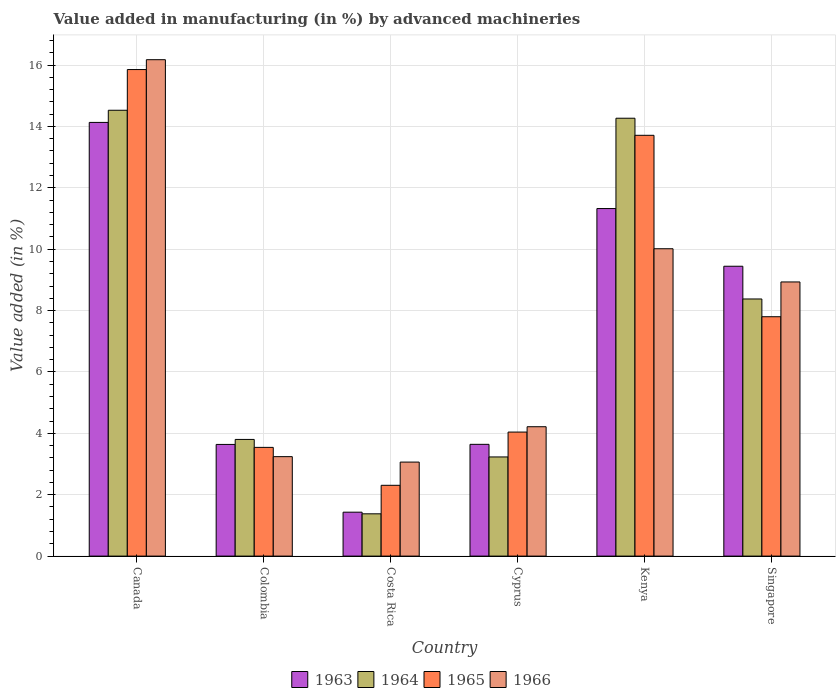How many groups of bars are there?
Keep it short and to the point. 6. Are the number of bars per tick equal to the number of legend labels?
Offer a very short reply. Yes. Are the number of bars on each tick of the X-axis equal?
Offer a terse response. Yes. How many bars are there on the 4th tick from the left?
Provide a succinct answer. 4. What is the label of the 4th group of bars from the left?
Keep it short and to the point. Cyprus. In how many cases, is the number of bars for a given country not equal to the number of legend labels?
Your answer should be very brief. 0. What is the percentage of value added in manufacturing by advanced machineries in 1963 in Colombia?
Give a very brief answer. 3.64. Across all countries, what is the maximum percentage of value added in manufacturing by advanced machineries in 1965?
Provide a short and direct response. 15.85. Across all countries, what is the minimum percentage of value added in manufacturing by advanced machineries in 1964?
Your answer should be very brief. 1.38. In which country was the percentage of value added in manufacturing by advanced machineries in 1966 maximum?
Make the answer very short. Canada. In which country was the percentage of value added in manufacturing by advanced machineries in 1966 minimum?
Your answer should be very brief. Costa Rica. What is the total percentage of value added in manufacturing by advanced machineries in 1965 in the graph?
Provide a succinct answer. 47.25. What is the difference between the percentage of value added in manufacturing by advanced machineries in 1965 in Canada and that in Colombia?
Make the answer very short. 12.31. What is the difference between the percentage of value added in manufacturing by advanced machineries in 1965 in Cyprus and the percentage of value added in manufacturing by advanced machineries in 1964 in Colombia?
Keep it short and to the point. 0.24. What is the average percentage of value added in manufacturing by advanced machineries in 1963 per country?
Your response must be concise. 7.27. What is the difference between the percentage of value added in manufacturing by advanced machineries of/in 1963 and percentage of value added in manufacturing by advanced machineries of/in 1964 in Costa Rica?
Your answer should be compact. 0.05. What is the ratio of the percentage of value added in manufacturing by advanced machineries in 1964 in Canada to that in Kenya?
Ensure brevity in your answer.  1.02. What is the difference between the highest and the second highest percentage of value added in manufacturing by advanced machineries in 1965?
Your answer should be very brief. -5.91. What is the difference between the highest and the lowest percentage of value added in manufacturing by advanced machineries in 1964?
Your answer should be very brief. 13.15. Is it the case that in every country, the sum of the percentage of value added in manufacturing by advanced machineries in 1963 and percentage of value added in manufacturing by advanced machineries in 1964 is greater than the sum of percentage of value added in manufacturing by advanced machineries in 1965 and percentage of value added in manufacturing by advanced machineries in 1966?
Provide a succinct answer. No. What does the 4th bar from the left in Cyprus represents?
Keep it short and to the point. 1966. What does the 1st bar from the right in Canada represents?
Give a very brief answer. 1966. Are all the bars in the graph horizontal?
Give a very brief answer. No. What is the difference between two consecutive major ticks on the Y-axis?
Provide a short and direct response. 2. Does the graph contain any zero values?
Make the answer very short. No. Where does the legend appear in the graph?
Keep it short and to the point. Bottom center. How many legend labels are there?
Make the answer very short. 4. What is the title of the graph?
Your answer should be compact. Value added in manufacturing (in %) by advanced machineries. What is the label or title of the Y-axis?
Keep it short and to the point. Value added (in %). What is the Value added (in %) in 1963 in Canada?
Keep it short and to the point. 14.13. What is the Value added (in %) in 1964 in Canada?
Your answer should be very brief. 14.53. What is the Value added (in %) in 1965 in Canada?
Provide a succinct answer. 15.85. What is the Value added (in %) in 1966 in Canada?
Ensure brevity in your answer.  16.17. What is the Value added (in %) in 1963 in Colombia?
Give a very brief answer. 3.64. What is the Value added (in %) of 1964 in Colombia?
Make the answer very short. 3.8. What is the Value added (in %) of 1965 in Colombia?
Make the answer very short. 3.54. What is the Value added (in %) in 1966 in Colombia?
Give a very brief answer. 3.24. What is the Value added (in %) of 1963 in Costa Rica?
Your answer should be very brief. 1.43. What is the Value added (in %) of 1964 in Costa Rica?
Ensure brevity in your answer.  1.38. What is the Value added (in %) in 1965 in Costa Rica?
Your answer should be compact. 2.31. What is the Value added (in %) in 1966 in Costa Rica?
Keep it short and to the point. 3.06. What is the Value added (in %) in 1963 in Cyprus?
Give a very brief answer. 3.64. What is the Value added (in %) of 1964 in Cyprus?
Your answer should be compact. 3.23. What is the Value added (in %) in 1965 in Cyprus?
Ensure brevity in your answer.  4.04. What is the Value added (in %) of 1966 in Cyprus?
Your answer should be compact. 4.22. What is the Value added (in %) in 1963 in Kenya?
Ensure brevity in your answer.  11.32. What is the Value added (in %) of 1964 in Kenya?
Offer a terse response. 14.27. What is the Value added (in %) in 1965 in Kenya?
Provide a short and direct response. 13.71. What is the Value added (in %) of 1966 in Kenya?
Keep it short and to the point. 10.01. What is the Value added (in %) in 1963 in Singapore?
Offer a very short reply. 9.44. What is the Value added (in %) of 1964 in Singapore?
Offer a terse response. 8.38. What is the Value added (in %) of 1965 in Singapore?
Make the answer very short. 7.8. What is the Value added (in %) in 1966 in Singapore?
Make the answer very short. 8.93. Across all countries, what is the maximum Value added (in %) of 1963?
Give a very brief answer. 14.13. Across all countries, what is the maximum Value added (in %) of 1964?
Offer a very short reply. 14.53. Across all countries, what is the maximum Value added (in %) of 1965?
Your answer should be compact. 15.85. Across all countries, what is the maximum Value added (in %) of 1966?
Your answer should be very brief. 16.17. Across all countries, what is the minimum Value added (in %) in 1963?
Give a very brief answer. 1.43. Across all countries, what is the minimum Value added (in %) in 1964?
Your answer should be very brief. 1.38. Across all countries, what is the minimum Value added (in %) of 1965?
Your response must be concise. 2.31. Across all countries, what is the minimum Value added (in %) of 1966?
Your response must be concise. 3.06. What is the total Value added (in %) in 1963 in the graph?
Provide a short and direct response. 43.61. What is the total Value added (in %) in 1964 in the graph?
Ensure brevity in your answer.  45.58. What is the total Value added (in %) of 1965 in the graph?
Your answer should be very brief. 47.25. What is the total Value added (in %) of 1966 in the graph?
Offer a very short reply. 45.64. What is the difference between the Value added (in %) in 1963 in Canada and that in Colombia?
Your answer should be compact. 10.49. What is the difference between the Value added (in %) in 1964 in Canada and that in Colombia?
Make the answer very short. 10.72. What is the difference between the Value added (in %) in 1965 in Canada and that in Colombia?
Offer a very short reply. 12.31. What is the difference between the Value added (in %) of 1966 in Canada and that in Colombia?
Give a very brief answer. 12.93. What is the difference between the Value added (in %) of 1963 in Canada and that in Costa Rica?
Your answer should be compact. 12.7. What is the difference between the Value added (in %) of 1964 in Canada and that in Costa Rica?
Offer a very short reply. 13.15. What is the difference between the Value added (in %) of 1965 in Canada and that in Costa Rica?
Keep it short and to the point. 13.55. What is the difference between the Value added (in %) in 1966 in Canada and that in Costa Rica?
Ensure brevity in your answer.  13.11. What is the difference between the Value added (in %) in 1963 in Canada and that in Cyprus?
Offer a very short reply. 10.49. What is the difference between the Value added (in %) in 1964 in Canada and that in Cyprus?
Make the answer very short. 11.3. What is the difference between the Value added (in %) in 1965 in Canada and that in Cyprus?
Provide a short and direct response. 11.81. What is the difference between the Value added (in %) in 1966 in Canada and that in Cyprus?
Your answer should be very brief. 11.96. What is the difference between the Value added (in %) of 1963 in Canada and that in Kenya?
Make the answer very short. 2.81. What is the difference between the Value added (in %) of 1964 in Canada and that in Kenya?
Give a very brief answer. 0.26. What is the difference between the Value added (in %) of 1965 in Canada and that in Kenya?
Offer a terse response. 2.14. What is the difference between the Value added (in %) in 1966 in Canada and that in Kenya?
Your answer should be very brief. 6.16. What is the difference between the Value added (in %) in 1963 in Canada and that in Singapore?
Keep it short and to the point. 4.69. What is the difference between the Value added (in %) of 1964 in Canada and that in Singapore?
Provide a succinct answer. 6.15. What is the difference between the Value added (in %) in 1965 in Canada and that in Singapore?
Offer a terse response. 8.05. What is the difference between the Value added (in %) in 1966 in Canada and that in Singapore?
Your answer should be very brief. 7.24. What is the difference between the Value added (in %) of 1963 in Colombia and that in Costa Rica?
Provide a short and direct response. 2.21. What is the difference between the Value added (in %) of 1964 in Colombia and that in Costa Rica?
Your answer should be very brief. 2.42. What is the difference between the Value added (in %) in 1965 in Colombia and that in Costa Rica?
Your response must be concise. 1.24. What is the difference between the Value added (in %) of 1966 in Colombia and that in Costa Rica?
Provide a short and direct response. 0.18. What is the difference between the Value added (in %) in 1963 in Colombia and that in Cyprus?
Offer a terse response. -0. What is the difference between the Value added (in %) of 1964 in Colombia and that in Cyprus?
Your answer should be very brief. 0.57. What is the difference between the Value added (in %) in 1965 in Colombia and that in Cyprus?
Ensure brevity in your answer.  -0.5. What is the difference between the Value added (in %) of 1966 in Colombia and that in Cyprus?
Ensure brevity in your answer.  -0.97. What is the difference between the Value added (in %) in 1963 in Colombia and that in Kenya?
Your answer should be compact. -7.69. What is the difference between the Value added (in %) of 1964 in Colombia and that in Kenya?
Provide a short and direct response. -10.47. What is the difference between the Value added (in %) of 1965 in Colombia and that in Kenya?
Your answer should be compact. -10.17. What is the difference between the Value added (in %) of 1966 in Colombia and that in Kenya?
Provide a short and direct response. -6.77. What is the difference between the Value added (in %) of 1963 in Colombia and that in Singapore?
Your answer should be very brief. -5.81. What is the difference between the Value added (in %) in 1964 in Colombia and that in Singapore?
Provide a succinct answer. -4.58. What is the difference between the Value added (in %) in 1965 in Colombia and that in Singapore?
Give a very brief answer. -4.26. What is the difference between the Value added (in %) in 1966 in Colombia and that in Singapore?
Give a very brief answer. -5.69. What is the difference between the Value added (in %) in 1963 in Costa Rica and that in Cyprus?
Keep it short and to the point. -2.21. What is the difference between the Value added (in %) in 1964 in Costa Rica and that in Cyprus?
Offer a very short reply. -1.85. What is the difference between the Value added (in %) of 1965 in Costa Rica and that in Cyprus?
Offer a terse response. -1.73. What is the difference between the Value added (in %) of 1966 in Costa Rica and that in Cyprus?
Offer a terse response. -1.15. What is the difference between the Value added (in %) of 1963 in Costa Rica and that in Kenya?
Your answer should be very brief. -9.89. What is the difference between the Value added (in %) in 1964 in Costa Rica and that in Kenya?
Offer a very short reply. -12.89. What is the difference between the Value added (in %) in 1965 in Costa Rica and that in Kenya?
Give a very brief answer. -11.4. What is the difference between the Value added (in %) of 1966 in Costa Rica and that in Kenya?
Provide a short and direct response. -6.95. What is the difference between the Value added (in %) in 1963 in Costa Rica and that in Singapore?
Give a very brief answer. -8.01. What is the difference between the Value added (in %) of 1964 in Costa Rica and that in Singapore?
Offer a terse response. -7. What is the difference between the Value added (in %) in 1965 in Costa Rica and that in Singapore?
Give a very brief answer. -5.49. What is the difference between the Value added (in %) in 1966 in Costa Rica and that in Singapore?
Your response must be concise. -5.87. What is the difference between the Value added (in %) in 1963 in Cyprus and that in Kenya?
Provide a short and direct response. -7.68. What is the difference between the Value added (in %) in 1964 in Cyprus and that in Kenya?
Keep it short and to the point. -11.04. What is the difference between the Value added (in %) in 1965 in Cyprus and that in Kenya?
Keep it short and to the point. -9.67. What is the difference between the Value added (in %) of 1966 in Cyprus and that in Kenya?
Provide a short and direct response. -5.8. What is the difference between the Value added (in %) in 1963 in Cyprus and that in Singapore?
Your response must be concise. -5.8. What is the difference between the Value added (in %) of 1964 in Cyprus and that in Singapore?
Give a very brief answer. -5.15. What is the difference between the Value added (in %) of 1965 in Cyprus and that in Singapore?
Provide a short and direct response. -3.76. What is the difference between the Value added (in %) in 1966 in Cyprus and that in Singapore?
Make the answer very short. -4.72. What is the difference between the Value added (in %) in 1963 in Kenya and that in Singapore?
Provide a short and direct response. 1.88. What is the difference between the Value added (in %) of 1964 in Kenya and that in Singapore?
Your answer should be compact. 5.89. What is the difference between the Value added (in %) in 1965 in Kenya and that in Singapore?
Keep it short and to the point. 5.91. What is the difference between the Value added (in %) in 1966 in Kenya and that in Singapore?
Provide a short and direct response. 1.08. What is the difference between the Value added (in %) of 1963 in Canada and the Value added (in %) of 1964 in Colombia?
Keep it short and to the point. 10.33. What is the difference between the Value added (in %) in 1963 in Canada and the Value added (in %) in 1965 in Colombia?
Offer a terse response. 10.59. What is the difference between the Value added (in %) in 1963 in Canada and the Value added (in %) in 1966 in Colombia?
Provide a succinct answer. 10.89. What is the difference between the Value added (in %) of 1964 in Canada and the Value added (in %) of 1965 in Colombia?
Your response must be concise. 10.98. What is the difference between the Value added (in %) of 1964 in Canada and the Value added (in %) of 1966 in Colombia?
Provide a succinct answer. 11.29. What is the difference between the Value added (in %) in 1965 in Canada and the Value added (in %) in 1966 in Colombia?
Your answer should be very brief. 12.61. What is the difference between the Value added (in %) in 1963 in Canada and the Value added (in %) in 1964 in Costa Rica?
Keep it short and to the point. 12.75. What is the difference between the Value added (in %) in 1963 in Canada and the Value added (in %) in 1965 in Costa Rica?
Your response must be concise. 11.82. What is the difference between the Value added (in %) of 1963 in Canada and the Value added (in %) of 1966 in Costa Rica?
Provide a succinct answer. 11.07. What is the difference between the Value added (in %) of 1964 in Canada and the Value added (in %) of 1965 in Costa Rica?
Provide a short and direct response. 12.22. What is the difference between the Value added (in %) of 1964 in Canada and the Value added (in %) of 1966 in Costa Rica?
Your response must be concise. 11.46. What is the difference between the Value added (in %) in 1965 in Canada and the Value added (in %) in 1966 in Costa Rica?
Offer a very short reply. 12.79. What is the difference between the Value added (in %) in 1963 in Canada and the Value added (in %) in 1964 in Cyprus?
Make the answer very short. 10.9. What is the difference between the Value added (in %) in 1963 in Canada and the Value added (in %) in 1965 in Cyprus?
Make the answer very short. 10.09. What is the difference between the Value added (in %) in 1963 in Canada and the Value added (in %) in 1966 in Cyprus?
Your response must be concise. 9.92. What is the difference between the Value added (in %) in 1964 in Canada and the Value added (in %) in 1965 in Cyprus?
Provide a succinct answer. 10.49. What is the difference between the Value added (in %) of 1964 in Canada and the Value added (in %) of 1966 in Cyprus?
Your response must be concise. 10.31. What is the difference between the Value added (in %) in 1965 in Canada and the Value added (in %) in 1966 in Cyprus?
Keep it short and to the point. 11.64. What is the difference between the Value added (in %) in 1963 in Canada and the Value added (in %) in 1964 in Kenya?
Your answer should be compact. -0.14. What is the difference between the Value added (in %) in 1963 in Canada and the Value added (in %) in 1965 in Kenya?
Offer a very short reply. 0.42. What is the difference between the Value added (in %) in 1963 in Canada and the Value added (in %) in 1966 in Kenya?
Your answer should be very brief. 4.12. What is the difference between the Value added (in %) in 1964 in Canada and the Value added (in %) in 1965 in Kenya?
Ensure brevity in your answer.  0.82. What is the difference between the Value added (in %) of 1964 in Canada and the Value added (in %) of 1966 in Kenya?
Offer a very short reply. 4.51. What is the difference between the Value added (in %) in 1965 in Canada and the Value added (in %) in 1966 in Kenya?
Ensure brevity in your answer.  5.84. What is the difference between the Value added (in %) of 1963 in Canada and the Value added (in %) of 1964 in Singapore?
Give a very brief answer. 5.75. What is the difference between the Value added (in %) in 1963 in Canada and the Value added (in %) in 1965 in Singapore?
Provide a succinct answer. 6.33. What is the difference between the Value added (in %) in 1963 in Canada and the Value added (in %) in 1966 in Singapore?
Provide a succinct answer. 5.2. What is the difference between the Value added (in %) in 1964 in Canada and the Value added (in %) in 1965 in Singapore?
Provide a short and direct response. 6.73. What is the difference between the Value added (in %) of 1964 in Canada and the Value added (in %) of 1966 in Singapore?
Provide a succinct answer. 5.59. What is the difference between the Value added (in %) of 1965 in Canada and the Value added (in %) of 1966 in Singapore?
Your answer should be very brief. 6.92. What is the difference between the Value added (in %) of 1963 in Colombia and the Value added (in %) of 1964 in Costa Rica?
Provide a short and direct response. 2.26. What is the difference between the Value added (in %) in 1963 in Colombia and the Value added (in %) in 1965 in Costa Rica?
Provide a short and direct response. 1.33. What is the difference between the Value added (in %) of 1963 in Colombia and the Value added (in %) of 1966 in Costa Rica?
Your answer should be very brief. 0.57. What is the difference between the Value added (in %) in 1964 in Colombia and the Value added (in %) in 1965 in Costa Rica?
Your answer should be very brief. 1.49. What is the difference between the Value added (in %) in 1964 in Colombia and the Value added (in %) in 1966 in Costa Rica?
Make the answer very short. 0.74. What is the difference between the Value added (in %) in 1965 in Colombia and the Value added (in %) in 1966 in Costa Rica?
Your response must be concise. 0.48. What is the difference between the Value added (in %) of 1963 in Colombia and the Value added (in %) of 1964 in Cyprus?
Your answer should be very brief. 0.41. What is the difference between the Value added (in %) of 1963 in Colombia and the Value added (in %) of 1965 in Cyprus?
Make the answer very short. -0.4. What is the difference between the Value added (in %) in 1963 in Colombia and the Value added (in %) in 1966 in Cyprus?
Ensure brevity in your answer.  -0.58. What is the difference between the Value added (in %) of 1964 in Colombia and the Value added (in %) of 1965 in Cyprus?
Give a very brief answer. -0.24. What is the difference between the Value added (in %) of 1964 in Colombia and the Value added (in %) of 1966 in Cyprus?
Offer a very short reply. -0.41. What is the difference between the Value added (in %) of 1965 in Colombia and the Value added (in %) of 1966 in Cyprus?
Provide a short and direct response. -0.67. What is the difference between the Value added (in %) in 1963 in Colombia and the Value added (in %) in 1964 in Kenya?
Offer a terse response. -10.63. What is the difference between the Value added (in %) of 1963 in Colombia and the Value added (in %) of 1965 in Kenya?
Your answer should be very brief. -10.07. What is the difference between the Value added (in %) in 1963 in Colombia and the Value added (in %) in 1966 in Kenya?
Provide a succinct answer. -6.38. What is the difference between the Value added (in %) in 1964 in Colombia and the Value added (in %) in 1965 in Kenya?
Your answer should be compact. -9.91. What is the difference between the Value added (in %) in 1964 in Colombia and the Value added (in %) in 1966 in Kenya?
Your answer should be very brief. -6.21. What is the difference between the Value added (in %) of 1965 in Colombia and the Value added (in %) of 1966 in Kenya?
Make the answer very short. -6.47. What is the difference between the Value added (in %) of 1963 in Colombia and the Value added (in %) of 1964 in Singapore?
Offer a very short reply. -4.74. What is the difference between the Value added (in %) of 1963 in Colombia and the Value added (in %) of 1965 in Singapore?
Your answer should be very brief. -4.16. What is the difference between the Value added (in %) of 1963 in Colombia and the Value added (in %) of 1966 in Singapore?
Your response must be concise. -5.29. What is the difference between the Value added (in %) in 1964 in Colombia and the Value added (in %) in 1965 in Singapore?
Provide a short and direct response. -4. What is the difference between the Value added (in %) of 1964 in Colombia and the Value added (in %) of 1966 in Singapore?
Make the answer very short. -5.13. What is the difference between the Value added (in %) of 1965 in Colombia and the Value added (in %) of 1966 in Singapore?
Provide a succinct answer. -5.39. What is the difference between the Value added (in %) in 1963 in Costa Rica and the Value added (in %) in 1964 in Cyprus?
Offer a terse response. -1.8. What is the difference between the Value added (in %) in 1963 in Costa Rica and the Value added (in %) in 1965 in Cyprus?
Your answer should be compact. -2.61. What is the difference between the Value added (in %) of 1963 in Costa Rica and the Value added (in %) of 1966 in Cyprus?
Provide a short and direct response. -2.78. What is the difference between the Value added (in %) of 1964 in Costa Rica and the Value added (in %) of 1965 in Cyprus?
Give a very brief answer. -2.66. What is the difference between the Value added (in %) of 1964 in Costa Rica and the Value added (in %) of 1966 in Cyprus?
Give a very brief answer. -2.84. What is the difference between the Value added (in %) of 1965 in Costa Rica and the Value added (in %) of 1966 in Cyprus?
Give a very brief answer. -1.91. What is the difference between the Value added (in %) of 1963 in Costa Rica and the Value added (in %) of 1964 in Kenya?
Provide a succinct answer. -12.84. What is the difference between the Value added (in %) in 1963 in Costa Rica and the Value added (in %) in 1965 in Kenya?
Your answer should be very brief. -12.28. What is the difference between the Value added (in %) of 1963 in Costa Rica and the Value added (in %) of 1966 in Kenya?
Provide a short and direct response. -8.58. What is the difference between the Value added (in %) of 1964 in Costa Rica and the Value added (in %) of 1965 in Kenya?
Provide a short and direct response. -12.33. What is the difference between the Value added (in %) of 1964 in Costa Rica and the Value added (in %) of 1966 in Kenya?
Offer a very short reply. -8.64. What is the difference between the Value added (in %) of 1965 in Costa Rica and the Value added (in %) of 1966 in Kenya?
Provide a succinct answer. -7.71. What is the difference between the Value added (in %) of 1963 in Costa Rica and the Value added (in %) of 1964 in Singapore?
Offer a terse response. -6.95. What is the difference between the Value added (in %) in 1963 in Costa Rica and the Value added (in %) in 1965 in Singapore?
Provide a short and direct response. -6.37. What is the difference between the Value added (in %) of 1963 in Costa Rica and the Value added (in %) of 1966 in Singapore?
Keep it short and to the point. -7.5. What is the difference between the Value added (in %) in 1964 in Costa Rica and the Value added (in %) in 1965 in Singapore?
Your answer should be compact. -6.42. What is the difference between the Value added (in %) of 1964 in Costa Rica and the Value added (in %) of 1966 in Singapore?
Provide a short and direct response. -7.55. What is the difference between the Value added (in %) in 1965 in Costa Rica and the Value added (in %) in 1966 in Singapore?
Offer a very short reply. -6.63. What is the difference between the Value added (in %) in 1963 in Cyprus and the Value added (in %) in 1964 in Kenya?
Offer a very short reply. -10.63. What is the difference between the Value added (in %) in 1963 in Cyprus and the Value added (in %) in 1965 in Kenya?
Make the answer very short. -10.07. What is the difference between the Value added (in %) of 1963 in Cyprus and the Value added (in %) of 1966 in Kenya?
Provide a short and direct response. -6.37. What is the difference between the Value added (in %) of 1964 in Cyprus and the Value added (in %) of 1965 in Kenya?
Ensure brevity in your answer.  -10.48. What is the difference between the Value added (in %) in 1964 in Cyprus and the Value added (in %) in 1966 in Kenya?
Your response must be concise. -6.78. What is the difference between the Value added (in %) in 1965 in Cyprus and the Value added (in %) in 1966 in Kenya?
Make the answer very short. -5.97. What is the difference between the Value added (in %) in 1963 in Cyprus and the Value added (in %) in 1964 in Singapore?
Make the answer very short. -4.74. What is the difference between the Value added (in %) in 1963 in Cyprus and the Value added (in %) in 1965 in Singapore?
Ensure brevity in your answer.  -4.16. What is the difference between the Value added (in %) of 1963 in Cyprus and the Value added (in %) of 1966 in Singapore?
Provide a short and direct response. -5.29. What is the difference between the Value added (in %) of 1964 in Cyprus and the Value added (in %) of 1965 in Singapore?
Your answer should be very brief. -4.57. What is the difference between the Value added (in %) of 1964 in Cyprus and the Value added (in %) of 1966 in Singapore?
Make the answer very short. -5.7. What is the difference between the Value added (in %) of 1965 in Cyprus and the Value added (in %) of 1966 in Singapore?
Make the answer very short. -4.89. What is the difference between the Value added (in %) of 1963 in Kenya and the Value added (in %) of 1964 in Singapore?
Ensure brevity in your answer.  2.95. What is the difference between the Value added (in %) of 1963 in Kenya and the Value added (in %) of 1965 in Singapore?
Your response must be concise. 3.52. What is the difference between the Value added (in %) in 1963 in Kenya and the Value added (in %) in 1966 in Singapore?
Your answer should be compact. 2.39. What is the difference between the Value added (in %) in 1964 in Kenya and the Value added (in %) in 1965 in Singapore?
Offer a very short reply. 6.47. What is the difference between the Value added (in %) of 1964 in Kenya and the Value added (in %) of 1966 in Singapore?
Offer a very short reply. 5.33. What is the difference between the Value added (in %) in 1965 in Kenya and the Value added (in %) in 1966 in Singapore?
Your answer should be compact. 4.78. What is the average Value added (in %) of 1963 per country?
Provide a short and direct response. 7.27. What is the average Value added (in %) in 1964 per country?
Give a very brief answer. 7.6. What is the average Value added (in %) of 1965 per country?
Provide a short and direct response. 7.88. What is the average Value added (in %) of 1966 per country?
Your answer should be very brief. 7.61. What is the difference between the Value added (in %) of 1963 and Value added (in %) of 1964 in Canada?
Offer a terse response. -0.4. What is the difference between the Value added (in %) in 1963 and Value added (in %) in 1965 in Canada?
Keep it short and to the point. -1.72. What is the difference between the Value added (in %) in 1963 and Value added (in %) in 1966 in Canada?
Give a very brief answer. -2.04. What is the difference between the Value added (in %) in 1964 and Value added (in %) in 1965 in Canada?
Give a very brief answer. -1.33. What is the difference between the Value added (in %) in 1964 and Value added (in %) in 1966 in Canada?
Your answer should be very brief. -1.65. What is the difference between the Value added (in %) in 1965 and Value added (in %) in 1966 in Canada?
Make the answer very short. -0.32. What is the difference between the Value added (in %) in 1963 and Value added (in %) in 1964 in Colombia?
Offer a very short reply. -0.16. What is the difference between the Value added (in %) of 1963 and Value added (in %) of 1965 in Colombia?
Your answer should be compact. 0.1. What is the difference between the Value added (in %) of 1963 and Value added (in %) of 1966 in Colombia?
Make the answer very short. 0.4. What is the difference between the Value added (in %) in 1964 and Value added (in %) in 1965 in Colombia?
Your response must be concise. 0.26. What is the difference between the Value added (in %) of 1964 and Value added (in %) of 1966 in Colombia?
Ensure brevity in your answer.  0.56. What is the difference between the Value added (in %) in 1965 and Value added (in %) in 1966 in Colombia?
Your answer should be very brief. 0.3. What is the difference between the Value added (in %) of 1963 and Value added (in %) of 1964 in Costa Rica?
Make the answer very short. 0.05. What is the difference between the Value added (in %) of 1963 and Value added (in %) of 1965 in Costa Rica?
Provide a short and direct response. -0.88. What is the difference between the Value added (in %) of 1963 and Value added (in %) of 1966 in Costa Rica?
Your answer should be compact. -1.63. What is the difference between the Value added (in %) of 1964 and Value added (in %) of 1965 in Costa Rica?
Keep it short and to the point. -0.93. What is the difference between the Value added (in %) of 1964 and Value added (in %) of 1966 in Costa Rica?
Your response must be concise. -1.69. What is the difference between the Value added (in %) of 1965 and Value added (in %) of 1966 in Costa Rica?
Your answer should be very brief. -0.76. What is the difference between the Value added (in %) of 1963 and Value added (in %) of 1964 in Cyprus?
Provide a succinct answer. 0.41. What is the difference between the Value added (in %) of 1963 and Value added (in %) of 1965 in Cyprus?
Make the answer very short. -0.4. What is the difference between the Value added (in %) in 1963 and Value added (in %) in 1966 in Cyprus?
Provide a succinct answer. -0.57. What is the difference between the Value added (in %) in 1964 and Value added (in %) in 1965 in Cyprus?
Offer a very short reply. -0.81. What is the difference between the Value added (in %) in 1964 and Value added (in %) in 1966 in Cyprus?
Offer a terse response. -0.98. What is the difference between the Value added (in %) of 1965 and Value added (in %) of 1966 in Cyprus?
Offer a very short reply. -0.17. What is the difference between the Value added (in %) in 1963 and Value added (in %) in 1964 in Kenya?
Make the answer very short. -2.94. What is the difference between the Value added (in %) of 1963 and Value added (in %) of 1965 in Kenya?
Make the answer very short. -2.39. What is the difference between the Value added (in %) of 1963 and Value added (in %) of 1966 in Kenya?
Keep it short and to the point. 1.31. What is the difference between the Value added (in %) of 1964 and Value added (in %) of 1965 in Kenya?
Make the answer very short. 0.56. What is the difference between the Value added (in %) in 1964 and Value added (in %) in 1966 in Kenya?
Your response must be concise. 4.25. What is the difference between the Value added (in %) of 1965 and Value added (in %) of 1966 in Kenya?
Give a very brief answer. 3.7. What is the difference between the Value added (in %) in 1963 and Value added (in %) in 1964 in Singapore?
Give a very brief answer. 1.07. What is the difference between the Value added (in %) in 1963 and Value added (in %) in 1965 in Singapore?
Offer a terse response. 1.64. What is the difference between the Value added (in %) of 1963 and Value added (in %) of 1966 in Singapore?
Your response must be concise. 0.51. What is the difference between the Value added (in %) in 1964 and Value added (in %) in 1965 in Singapore?
Offer a terse response. 0.58. What is the difference between the Value added (in %) in 1964 and Value added (in %) in 1966 in Singapore?
Keep it short and to the point. -0.55. What is the difference between the Value added (in %) of 1965 and Value added (in %) of 1966 in Singapore?
Give a very brief answer. -1.13. What is the ratio of the Value added (in %) of 1963 in Canada to that in Colombia?
Make the answer very short. 3.88. What is the ratio of the Value added (in %) of 1964 in Canada to that in Colombia?
Ensure brevity in your answer.  3.82. What is the ratio of the Value added (in %) of 1965 in Canada to that in Colombia?
Your response must be concise. 4.48. What is the ratio of the Value added (in %) in 1966 in Canada to that in Colombia?
Keep it short and to the point. 4.99. What is the ratio of the Value added (in %) in 1963 in Canada to that in Costa Rica?
Give a very brief answer. 9.87. What is the ratio of the Value added (in %) in 1964 in Canada to that in Costa Rica?
Your answer should be very brief. 10.54. What is the ratio of the Value added (in %) in 1965 in Canada to that in Costa Rica?
Provide a short and direct response. 6.87. What is the ratio of the Value added (in %) of 1966 in Canada to that in Costa Rica?
Offer a very short reply. 5.28. What is the ratio of the Value added (in %) in 1963 in Canada to that in Cyprus?
Your answer should be compact. 3.88. What is the ratio of the Value added (in %) in 1964 in Canada to that in Cyprus?
Provide a short and direct response. 4.5. What is the ratio of the Value added (in %) of 1965 in Canada to that in Cyprus?
Give a very brief answer. 3.92. What is the ratio of the Value added (in %) of 1966 in Canada to that in Cyprus?
Provide a succinct answer. 3.84. What is the ratio of the Value added (in %) of 1963 in Canada to that in Kenya?
Offer a very short reply. 1.25. What is the ratio of the Value added (in %) of 1964 in Canada to that in Kenya?
Make the answer very short. 1.02. What is the ratio of the Value added (in %) of 1965 in Canada to that in Kenya?
Your response must be concise. 1.16. What is the ratio of the Value added (in %) of 1966 in Canada to that in Kenya?
Give a very brief answer. 1.62. What is the ratio of the Value added (in %) in 1963 in Canada to that in Singapore?
Make the answer very short. 1.5. What is the ratio of the Value added (in %) in 1964 in Canada to that in Singapore?
Your response must be concise. 1.73. What is the ratio of the Value added (in %) of 1965 in Canada to that in Singapore?
Ensure brevity in your answer.  2.03. What is the ratio of the Value added (in %) in 1966 in Canada to that in Singapore?
Offer a terse response. 1.81. What is the ratio of the Value added (in %) of 1963 in Colombia to that in Costa Rica?
Provide a succinct answer. 2.54. What is the ratio of the Value added (in %) of 1964 in Colombia to that in Costa Rica?
Ensure brevity in your answer.  2.76. What is the ratio of the Value added (in %) of 1965 in Colombia to that in Costa Rica?
Offer a terse response. 1.54. What is the ratio of the Value added (in %) of 1966 in Colombia to that in Costa Rica?
Offer a terse response. 1.06. What is the ratio of the Value added (in %) of 1963 in Colombia to that in Cyprus?
Ensure brevity in your answer.  1. What is the ratio of the Value added (in %) of 1964 in Colombia to that in Cyprus?
Provide a succinct answer. 1.18. What is the ratio of the Value added (in %) in 1965 in Colombia to that in Cyprus?
Keep it short and to the point. 0.88. What is the ratio of the Value added (in %) in 1966 in Colombia to that in Cyprus?
Give a very brief answer. 0.77. What is the ratio of the Value added (in %) of 1963 in Colombia to that in Kenya?
Offer a very short reply. 0.32. What is the ratio of the Value added (in %) in 1964 in Colombia to that in Kenya?
Offer a terse response. 0.27. What is the ratio of the Value added (in %) of 1965 in Colombia to that in Kenya?
Offer a very short reply. 0.26. What is the ratio of the Value added (in %) in 1966 in Colombia to that in Kenya?
Ensure brevity in your answer.  0.32. What is the ratio of the Value added (in %) in 1963 in Colombia to that in Singapore?
Make the answer very short. 0.39. What is the ratio of the Value added (in %) of 1964 in Colombia to that in Singapore?
Offer a terse response. 0.45. What is the ratio of the Value added (in %) in 1965 in Colombia to that in Singapore?
Keep it short and to the point. 0.45. What is the ratio of the Value added (in %) of 1966 in Colombia to that in Singapore?
Make the answer very short. 0.36. What is the ratio of the Value added (in %) in 1963 in Costa Rica to that in Cyprus?
Offer a terse response. 0.39. What is the ratio of the Value added (in %) in 1964 in Costa Rica to that in Cyprus?
Keep it short and to the point. 0.43. What is the ratio of the Value added (in %) of 1965 in Costa Rica to that in Cyprus?
Keep it short and to the point. 0.57. What is the ratio of the Value added (in %) of 1966 in Costa Rica to that in Cyprus?
Provide a short and direct response. 0.73. What is the ratio of the Value added (in %) in 1963 in Costa Rica to that in Kenya?
Your response must be concise. 0.13. What is the ratio of the Value added (in %) in 1964 in Costa Rica to that in Kenya?
Offer a very short reply. 0.1. What is the ratio of the Value added (in %) of 1965 in Costa Rica to that in Kenya?
Give a very brief answer. 0.17. What is the ratio of the Value added (in %) in 1966 in Costa Rica to that in Kenya?
Provide a short and direct response. 0.31. What is the ratio of the Value added (in %) of 1963 in Costa Rica to that in Singapore?
Ensure brevity in your answer.  0.15. What is the ratio of the Value added (in %) in 1964 in Costa Rica to that in Singapore?
Offer a terse response. 0.16. What is the ratio of the Value added (in %) of 1965 in Costa Rica to that in Singapore?
Provide a succinct answer. 0.3. What is the ratio of the Value added (in %) in 1966 in Costa Rica to that in Singapore?
Provide a succinct answer. 0.34. What is the ratio of the Value added (in %) in 1963 in Cyprus to that in Kenya?
Make the answer very short. 0.32. What is the ratio of the Value added (in %) of 1964 in Cyprus to that in Kenya?
Keep it short and to the point. 0.23. What is the ratio of the Value added (in %) in 1965 in Cyprus to that in Kenya?
Your answer should be compact. 0.29. What is the ratio of the Value added (in %) in 1966 in Cyprus to that in Kenya?
Keep it short and to the point. 0.42. What is the ratio of the Value added (in %) of 1963 in Cyprus to that in Singapore?
Offer a terse response. 0.39. What is the ratio of the Value added (in %) in 1964 in Cyprus to that in Singapore?
Ensure brevity in your answer.  0.39. What is the ratio of the Value added (in %) of 1965 in Cyprus to that in Singapore?
Your answer should be very brief. 0.52. What is the ratio of the Value added (in %) of 1966 in Cyprus to that in Singapore?
Offer a very short reply. 0.47. What is the ratio of the Value added (in %) of 1963 in Kenya to that in Singapore?
Your answer should be compact. 1.2. What is the ratio of the Value added (in %) in 1964 in Kenya to that in Singapore?
Offer a terse response. 1.7. What is the ratio of the Value added (in %) in 1965 in Kenya to that in Singapore?
Give a very brief answer. 1.76. What is the ratio of the Value added (in %) of 1966 in Kenya to that in Singapore?
Ensure brevity in your answer.  1.12. What is the difference between the highest and the second highest Value added (in %) of 1963?
Make the answer very short. 2.81. What is the difference between the highest and the second highest Value added (in %) in 1964?
Offer a terse response. 0.26. What is the difference between the highest and the second highest Value added (in %) in 1965?
Offer a very short reply. 2.14. What is the difference between the highest and the second highest Value added (in %) in 1966?
Offer a very short reply. 6.16. What is the difference between the highest and the lowest Value added (in %) of 1963?
Your answer should be very brief. 12.7. What is the difference between the highest and the lowest Value added (in %) in 1964?
Make the answer very short. 13.15. What is the difference between the highest and the lowest Value added (in %) in 1965?
Provide a succinct answer. 13.55. What is the difference between the highest and the lowest Value added (in %) of 1966?
Your response must be concise. 13.11. 